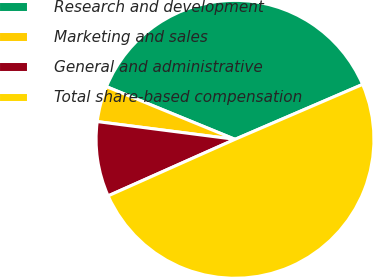Convert chart to OTSL. <chart><loc_0><loc_0><loc_500><loc_500><pie_chart><fcel>Research and development<fcel>Marketing and sales<fcel>General and administrative<fcel>Total share-based compensation<nl><fcel>37.34%<fcel>4.15%<fcel>8.71%<fcel>49.79%<nl></chart> 